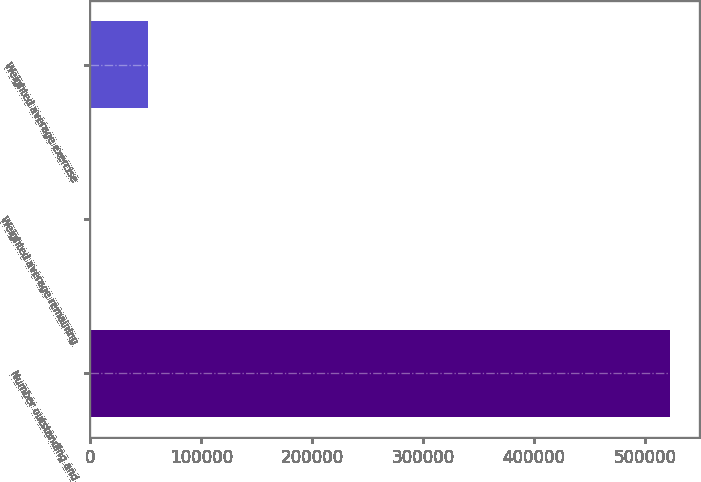Convert chart. <chart><loc_0><loc_0><loc_500><loc_500><bar_chart><fcel>Number outstanding and<fcel>Weighted average remaining<fcel>Weighted average exercise<nl><fcel>523083<fcel>1.5<fcel>52309.7<nl></chart> 